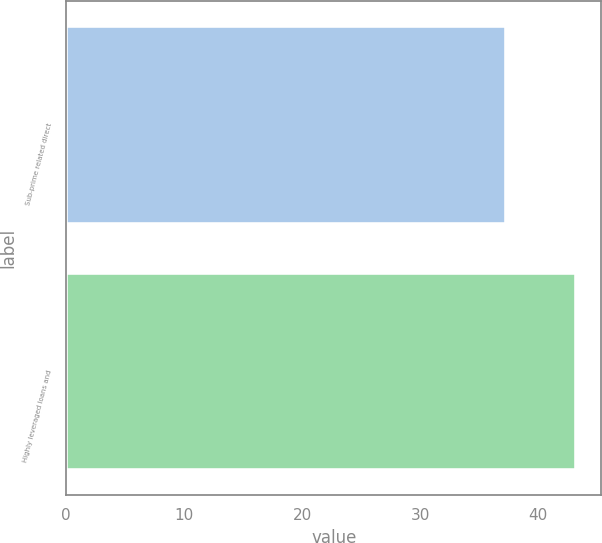Convert chart. <chart><loc_0><loc_0><loc_500><loc_500><bar_chart><fcel>Sub-prime related direct<fcel>Highly leveraged loans and<nl><fcel>37.3<fcel>43.2<nl></chart> 